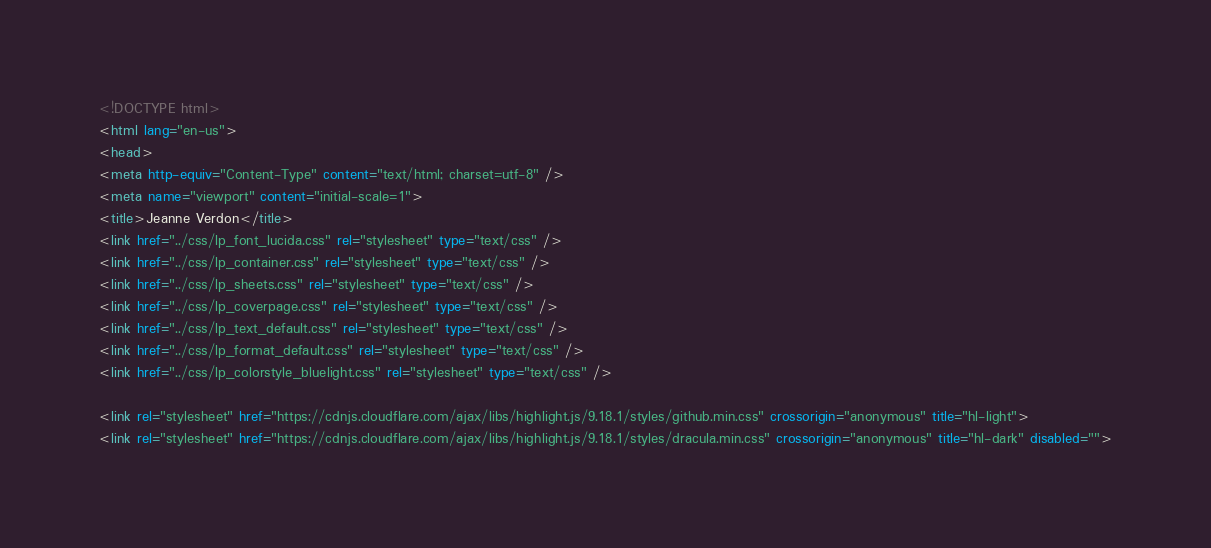Convert code to text. <code><loc_0><loc_0><loc_500><loc_500><_HTML_><!DOCTYPE html>
<html lang="en-us">
<head>
<meta http-equiv="Content-Type" content="text/html; charset=utf-8" />
<meta name="viewport" content="initial-scale=1">
<title>Jeanne Verdon</title>
<link href="../css/lp_font_lucida.css" rel="stylesheet" type="text/css" />
<link href="../css/lp_container.css" rel="stylesheet" type="text/css" />
<link href="../css/lp_sheets.css" rel="stylesheet" type="text/css" />
<link href="../css/lp_coverpage.css" rel="stylesheet" type="text/css" />
<link href="../css/lp_text_default.css" rel="stylesheet" type="text/css" />
<link href="../css/lp_format_default.css" rel="stylesheet" type="text/css" />
<link href="../css/lp_colorstyle_bluelight.css" rel="stylesheet" type="text/css" />

<link rel="stylesheet" href="https://cdnjs.cloudflare.com/ajax/libs/highlight.js/9.18.1/styles/github.min.css" crossorigin="anonymous" title="hl-light">
<link rel="stylesheet" href="https://cdnjs.cloudflare.com/ajax/libs/highlight.js/9.18.1/styles/dracula.min.css" crossorigin="anonymous" title="hl-dark" disabled=""></code> 